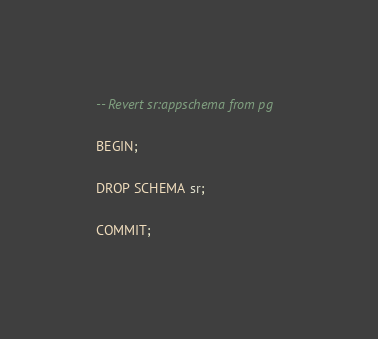Convert code to text. <code><loc_0><loc_0><loc_500><loc_500><_SQL_>-- Revert sr:appschema from pg

BEGIN;

DROP SCHEMA sr;

COMMIT;
</code> 